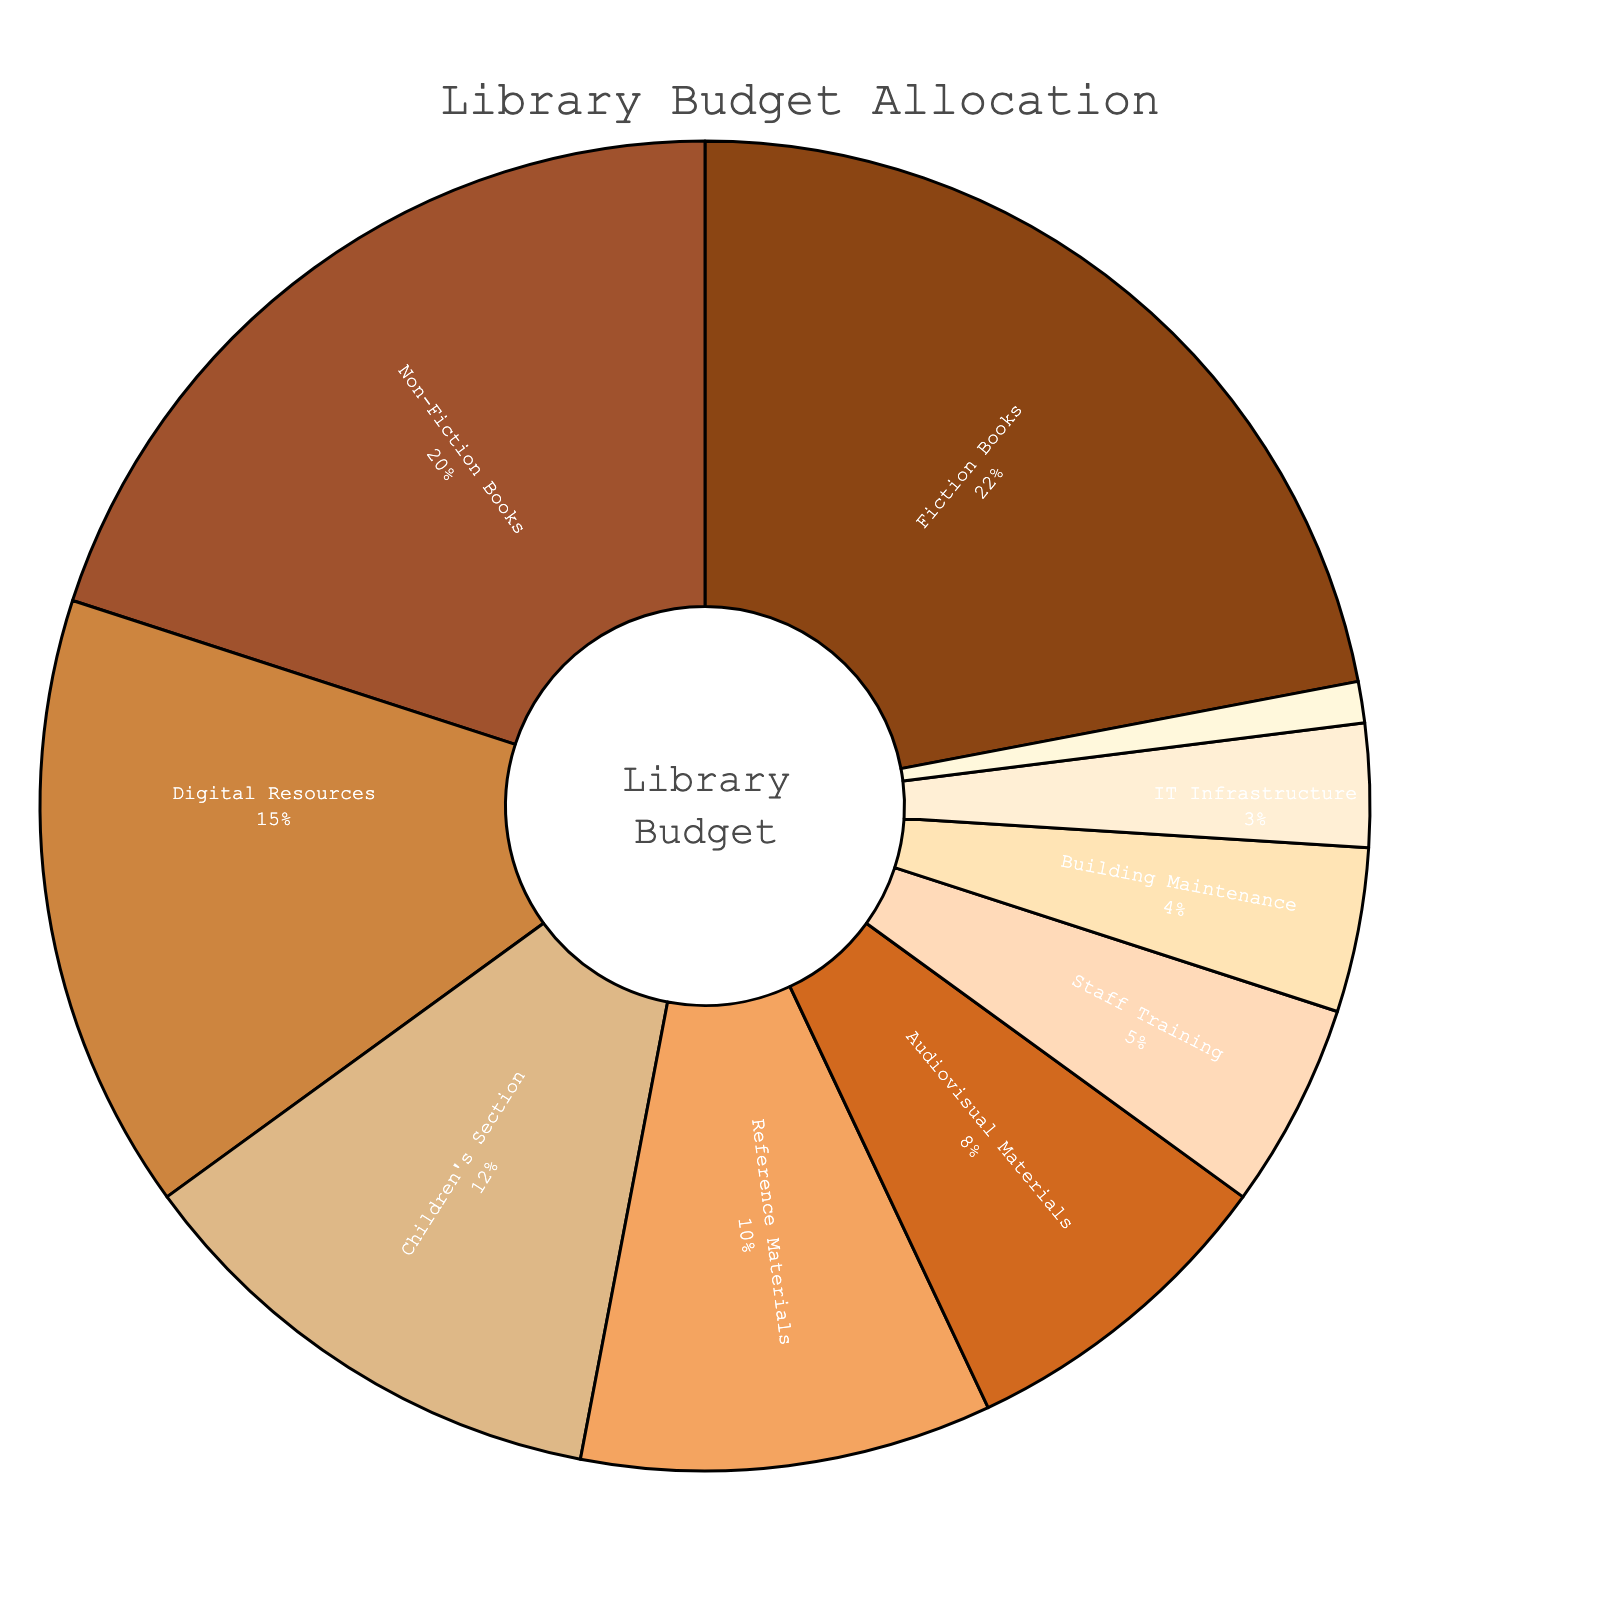Which department received the highest budget allocation? The pie chart indicates that the Fiction Books department received the highest budget allocation. This segment of the chart is visibly the largest.
Answer: Fiction Books What's the combined budget allocation for Children's Section and Reference Materials? To find the combined budget allocation, add the percentages for the Children's Section and Reference Materials: 12% + 10% = 22%.
Answer: 22% How much more budget allocation does Fiction Books have compared to Digital Resources? The budget allocation for Fiction Books is 22% and for Digital Resources is 15%. Subtract the allocation of Digital Resources from that of Fiction Books: 22% - 15% = 7%.
Answer: 7% Which two departments have the smallest budget allocation, and what do their budgets sum to? The Community Programs and IT Infrastructure departments have the smallest allocations at 1% and 3%, respectively. Adding these values: 1% + 3% = 4%.
Answer: Community Programs and IT Infrastructure; 4% What's the average budget allocation for the top three funded departments? The top three funded departments are Fiction Books (22%), Non-Fiction Books (20%), and Digital Resources (15%). Calculate the average: (22% + 20% + 15%) / 3 = 57% / 3 = 19%.
Answer: 19% Which department or service has a budget allocation equal to that of Children's Section and Building Maintenance combined? The Children's Section has a 12% allocation and Building Maintenance has a 4% allocation. Their combined allocation is 12% + 4% = 16%. The comparable department is not directly indicated in the chart.
Answer: None indicated Compare the budget allocation difference between Audiovisual Materials and Staff Training. The allocation for Audiovisual Materials is 8%, and for Staff Training, it is 5%. The difference is 8% - 5% = 3%.
Answer: 3% What percentage of the budget is allocated to departments/services with less than 10% each? Departments/services with less than 10% allocation are: Audiovisual Materials (8%), Staff Training (5%), Building Maintenance (4%), IT Infrastructure (3%), Community Programs (1%). Sum these allocations: 8% + 5% + 4% + 3% + 1% = 21%.
Answer: 21% 